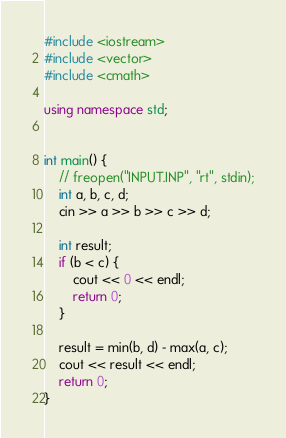<code> <loc_0><loc_0><loc_500><loc_500><_C++_>#include <iostream>
#include <vector>
#include <cmath>

using namespace std;


int main() {
    // freopen("INPUT.INP", "rt", stdin);
    int a, b, c, d;
    cin >> a >> b >> c >> d;

    int result;
    if (b < c) {
        cout << 0 << endl;
        return 0;
    }

    result = min(b, d) - max(a, c);
    cout << result << endl;
    return 0;
}
</code> 